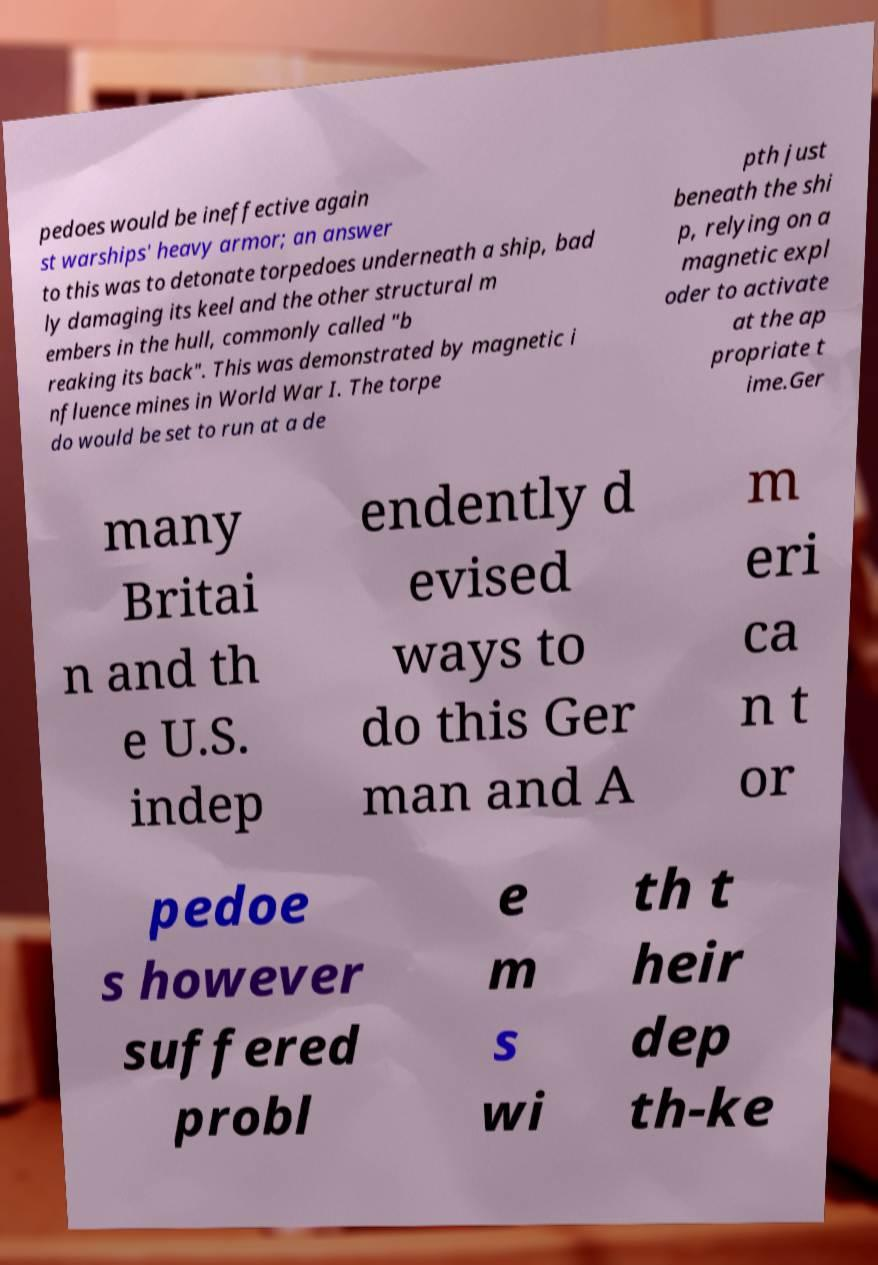Could you assist in decoding the text presented in this image and type it out clearly? pedoes would be ineffective again st warships' heavy armor; an answer to this was to detonate torpedoes underneath a ship, bad ly damaging its keel and the other structural m embers in the hull, commonly called "b reaking its back". This was demonstrated by magnetic i nfluence mines in World War I. The torpe do would be set to run at a de pth just beneath the shi p, relying on a magnetic expl oder to activate at the ap propriate t ime.Ger many Britai n and th e U.S. indep endently d evised ways to do this Ger man and A m eri ca n t or pedoe s however suffered probl e m s wi th t heir dep th-ke 